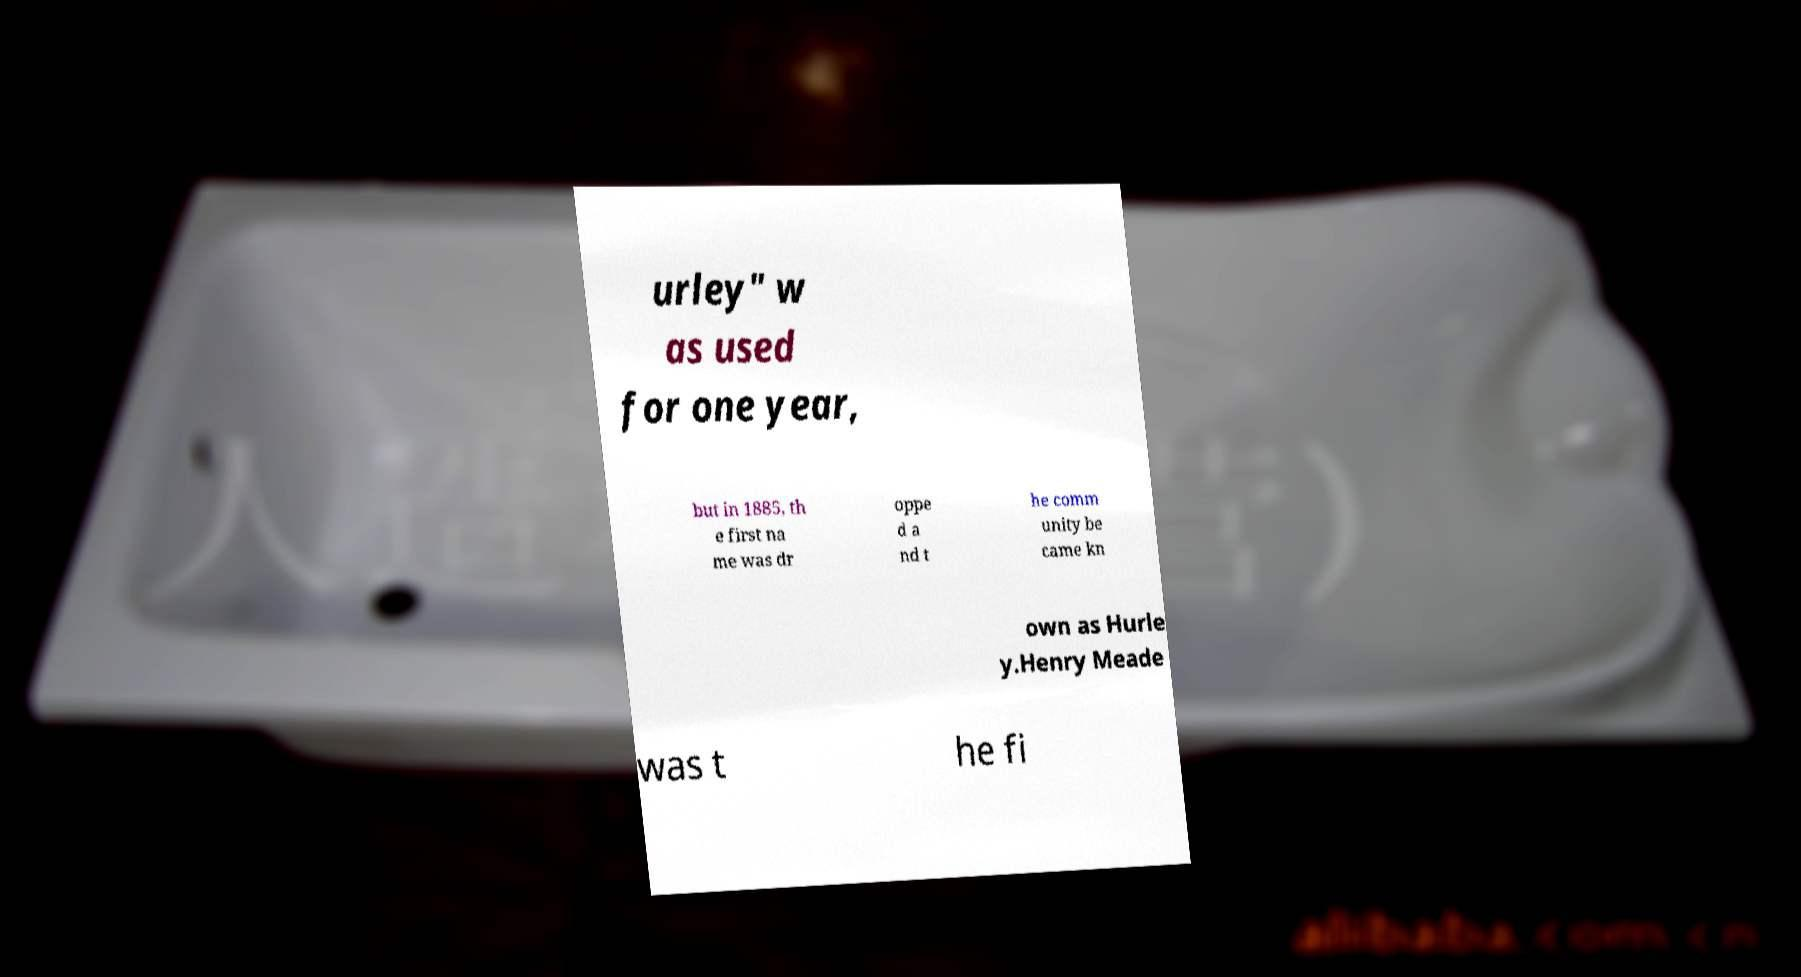Please identify and transcribe the text found in this image. urley" w as used for one year, but in 1885, th e first na me was dr oppe d a nd t he comm unity be came kn own as Hurle y.Henry Meade was t he fi 